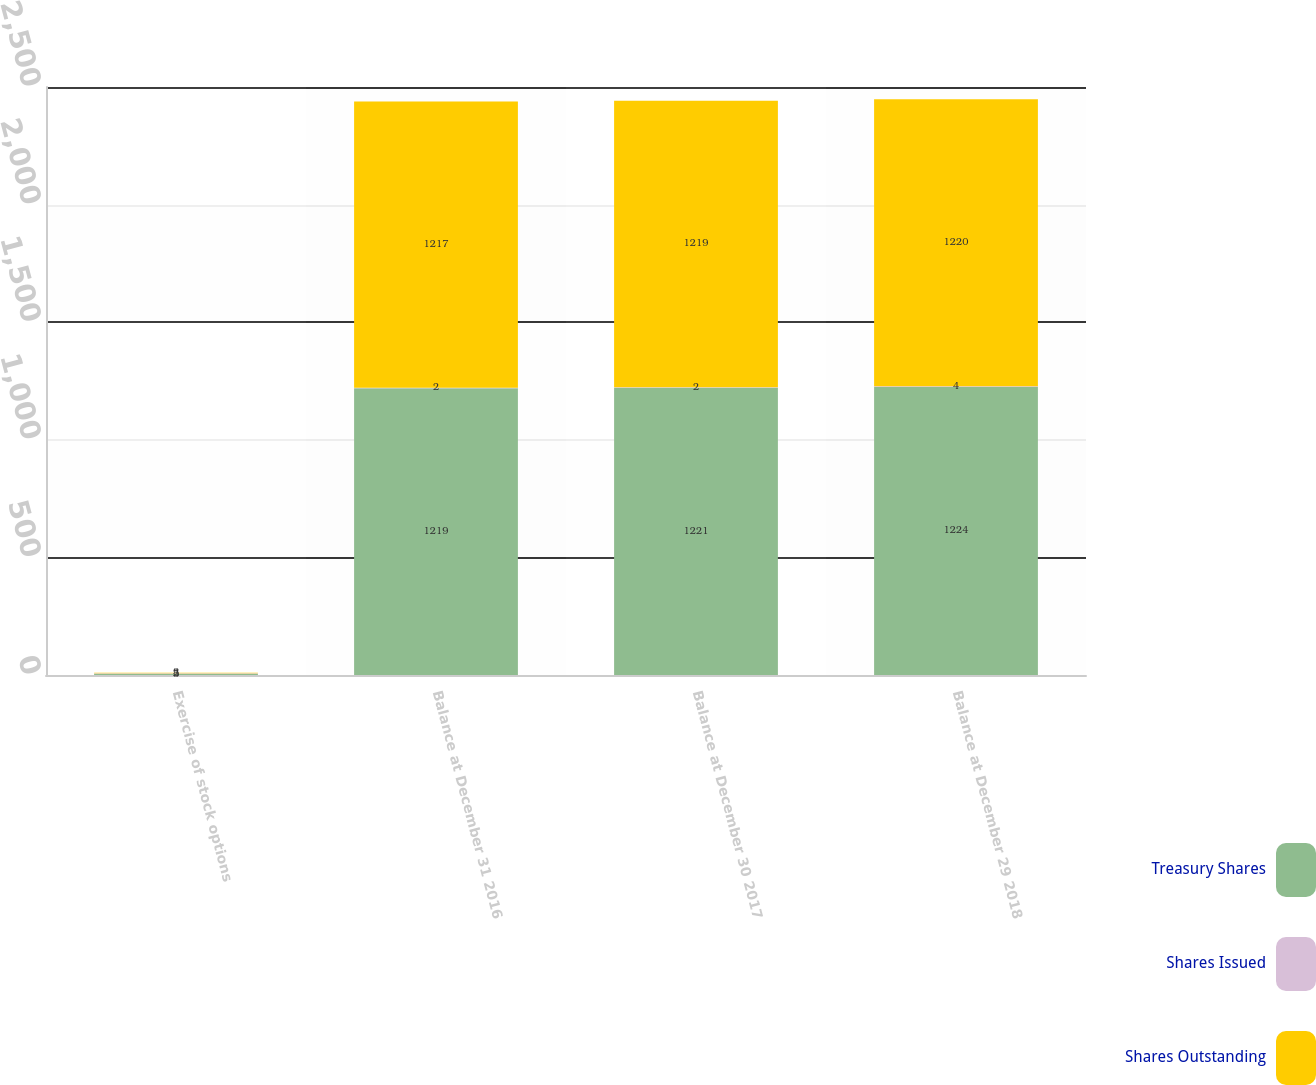<chart> <loc_0><loc_0><loc_500><loc_500><stacked_bar_chart><ecel><fcel>Exercise of stock options<fcel>Balance at December 31 2016<fcel>Balance at December 30 2017<fcel>Balance at December 29 2018<nl><fcel>Treasury Shares<fcel>5<fcel>1219<fcel>1221<fcel>1224<nl><fcel>Shares Issued<fcel>2<fcel>2<fcel>2<fcel>4<nl><fcel>Shares Outstanding<fcel>3<fcel>1217<fcel>1219<fcel>1220<nl></chart> 